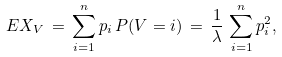<formula> <loc_0><loc_0><loc_500><loc_500>E X _ { V } \, = \, \sum _ { i = 1 } ^ { n } p _ { i } \, P ( V = i ) \, = \, \frac { 1 } { \lambda } \, \sum _ { i = 1 } ^ { n } p _ { i } ^ { 2 } ,</formula> 